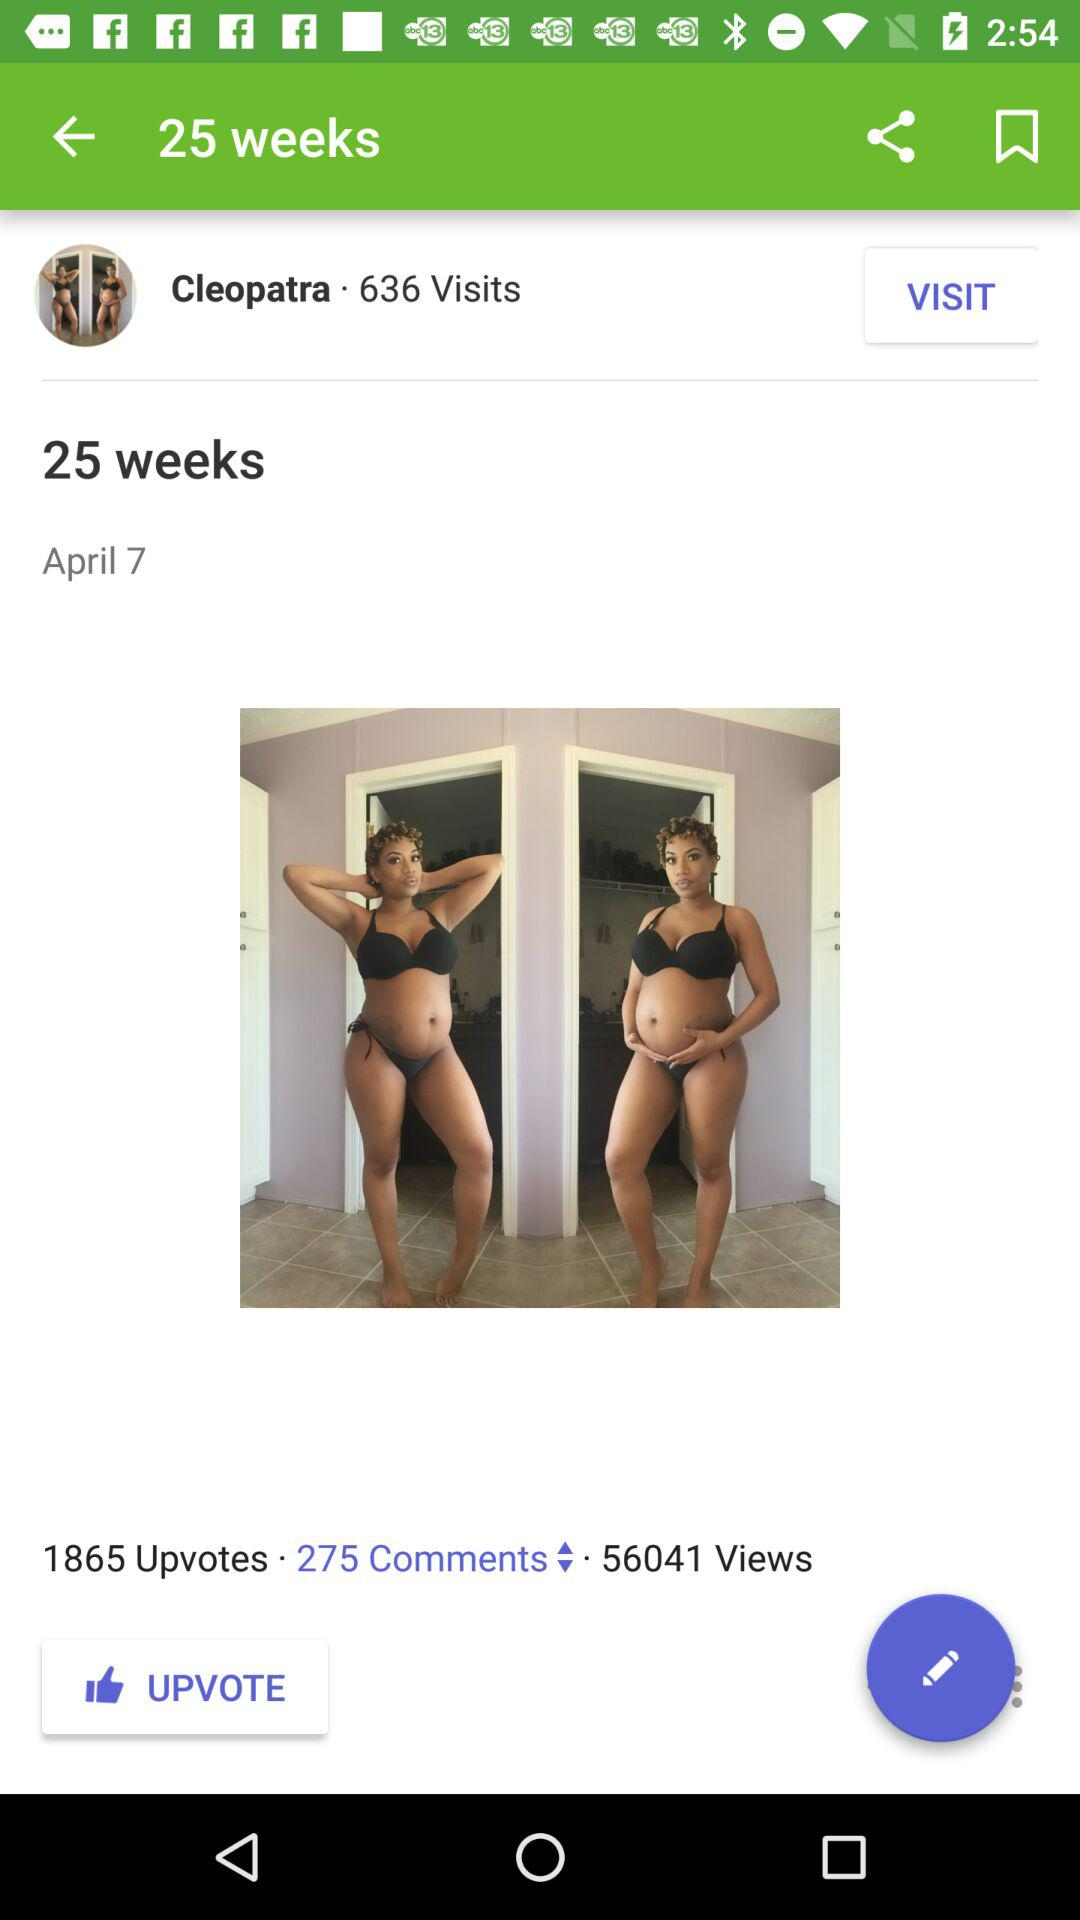How many people visited the post? The number of people who visited the post is 636. 